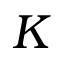Convert formula to latex. <formula><loc_0><loc_0><loc_500><loc_500>K</formula> 